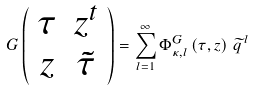<formula> <loc_0><loc_0><loc_500><loc_500>G \left ( \begin{array} { c c } \tau & z ^ { t } \\ z & \tilde { \tau } \end{array} \right ) = \sum _ { l = 1 } ^ { \infty } \Phi _ { \kappa , l } ^ { G } \left ( \tau , z \right ) \, \widetilde { q } ^ { \, l }</formula> 